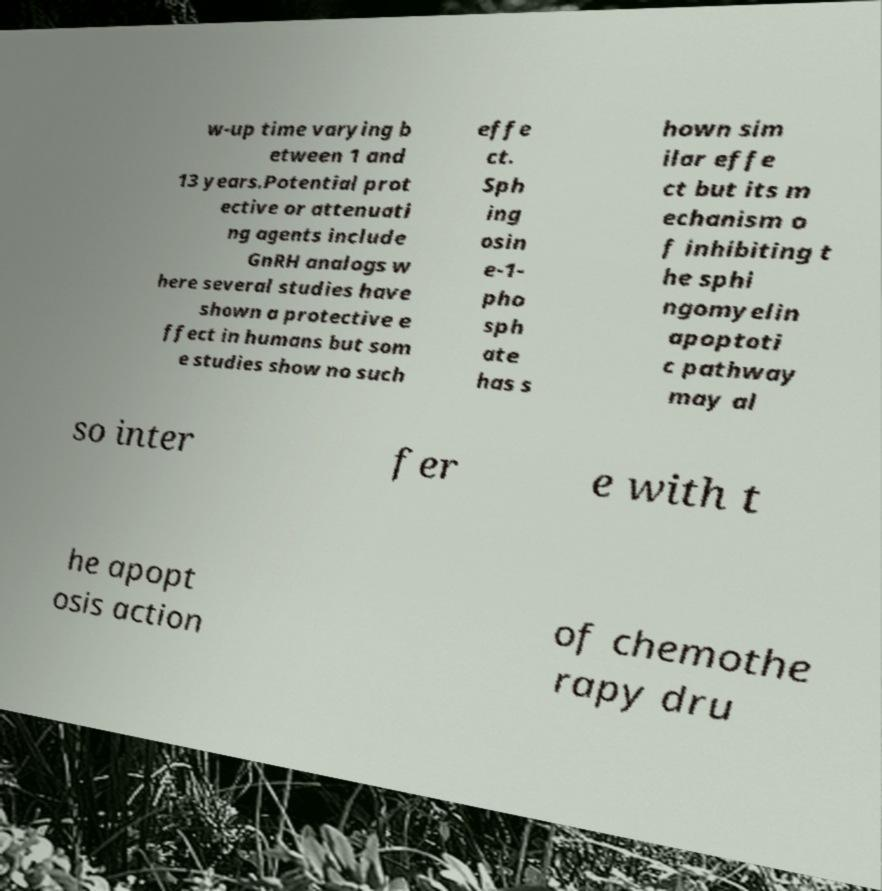Can you accurately transcribe the text from the provided image for me? w-up time varying b etween 1 and 13 years.Potential prot ective or attenuati ng agents include GnRH analogs w here several studies have shown a protective e ffect in humans but som e studies show no such effe ct. Sph ing osin e-1- pho sph ate has s hown sim ilar effe ct but its m echanism o f inhibiting t he sphi ngomyelin apoptoti c pathway may al so inter fer e with t he apopt osis action of chemothe rapy dru 